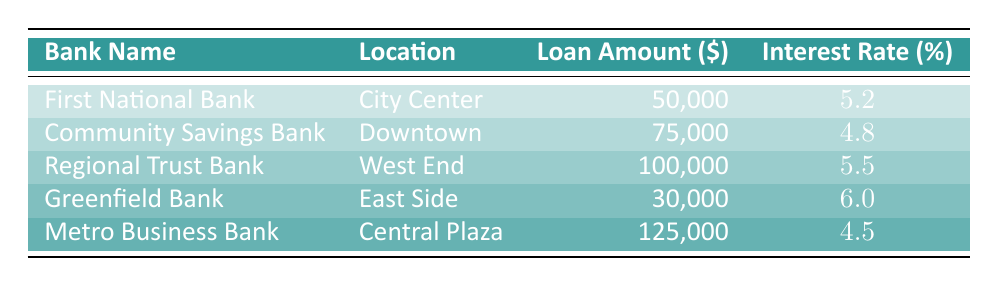What is the interest rate offered by Metro Business Bank? The table shows that Metro Business Bank offers an interest rate of 4.5%.
Answer: 4.5% Which bank has the highest loan amount listed? Upon examining the loan amounts, the highest one is from Metro Business Bank, which is 125,000.
Answer: 125,000 What is the average interest rate of the banks in the table? To find the average interest rate, we add all rates (5.2 + 4.8 + 5.5 + 6.0 + 4.5 = 26.0) and divide by the number of banks (5), resulting in an average of 26.0/5 = 5.2.
Answer: 5.2 Is the interest rate for Community Savings Bank lower than First National Bank? Community Savings Bank has an interest rate of 4.8%, which is lower than First National Bank's rate of 5.2%. So the statement is true.
Answer: Yes Which bank offers an interest rate that is equal to or greater than 5.5%? Looking through the table, both Regional Trust Bank (5.5%) and Greenfield Bank (6.0%) have interest rates equal to or greater than 5.5%.
Answer: Regional Trust Bank and Greenfield Bank What is the difference in interest rates between the bank with the highest and the bank with the lowest rate? The highest rate is 6.0% from Greenfield Bank, and the lowest is 4.5% from Metro Business Bank. The difference is 6.0 - 4.5 = 1.5%.
Answer: 1.5% Do all banks listed have an interest rate above 4%? Analyzing the interest rates, all banks have rates above 4%, so the statement is true.
Answer: Yes What is the total loan amount available across all banks? The total loan amount is the sum of the individual loan amounts: 50000 + 75000 + 100000 + 30000 + 125000 = 380000.
Answer: 380000 Which bank has the lowest interest rate and what is it? The bank with the lowest interest rate is Metro Business Bank, which has an interest rate of 4.5%.
Answer: Metro Business Bank, 4.5% 